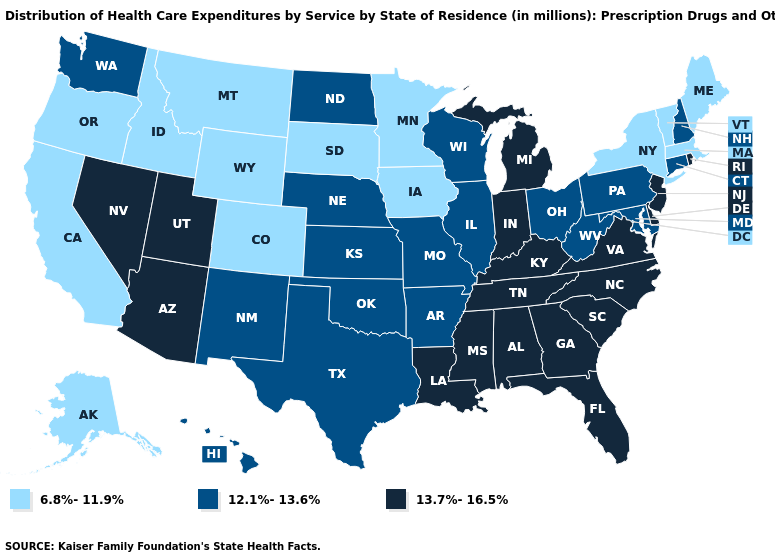How many symbols are there in the legend?
Write a very short answer. 3. Does New Jersey have the highest value in the Northeast?
Concise answer only. Yes. What is the highest value in the West ?
Keep it brief. 13.7%-16.5%. Does Michigan have the highest value in the USA?
Keep it brief. Yes. What is the highest value in the West ?
Give a very brief answer. 13.7%-16.5%. Among the states that border North Dakota , which have the highest value?
Short answer required. Minnesota, Montana, South Dakota. What is the lowest value in the USA?
Give a very brief answer. 6.8%-11.9%. Among the states that border Nevada , which have the lowest value?
Give a very brief answer. California, Idaho, Oregon. Name the states that have a value in the range 6.8%-11.9%?
Answer briefly. Alaska, California, Colorado, Idaho, Iowa, Maine, Massachusetts, Minnesota, Montana, New York, Oregon, South Dakota, Vermont, Wyoming. Name the states that have a value in the range 13.7%-16.5%?
Write a very short answer. Alabama, Arizona, Delaware, Florida, Georgia, Indiana, Kentucky, Louisiana, Michigan, Mississippi, Nevada, New Jersey, North Carolina, Rhode Island, South Carolina, Tennessee, Utah, Virginia. Name the states that have a value in the range 13.7%-16.5%?
Short answer required. Alabama, Arizona, Delaware, Florida, Georgia, Indiana, Kentucky, Louisiana, Michigan, Mississippi, Nevada, New Jersey, North Carolina, Rhode Island, South Carolina, Tennessee, Utah, Virginia. What is the highest value in the USA?
Give a very brief answer. 13.7%-16.5%. Is the legend a continuous bar?
Give a very brief answer. No. Among the states that border Idaho , does Nevada have the lowest value?
Keep it brief. No. 